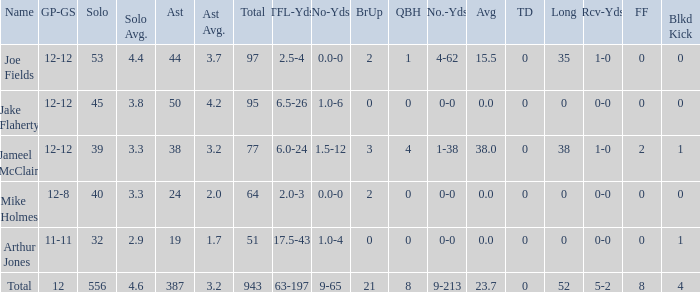How many tackle assists for the player who averages 23.7? 387.0. 